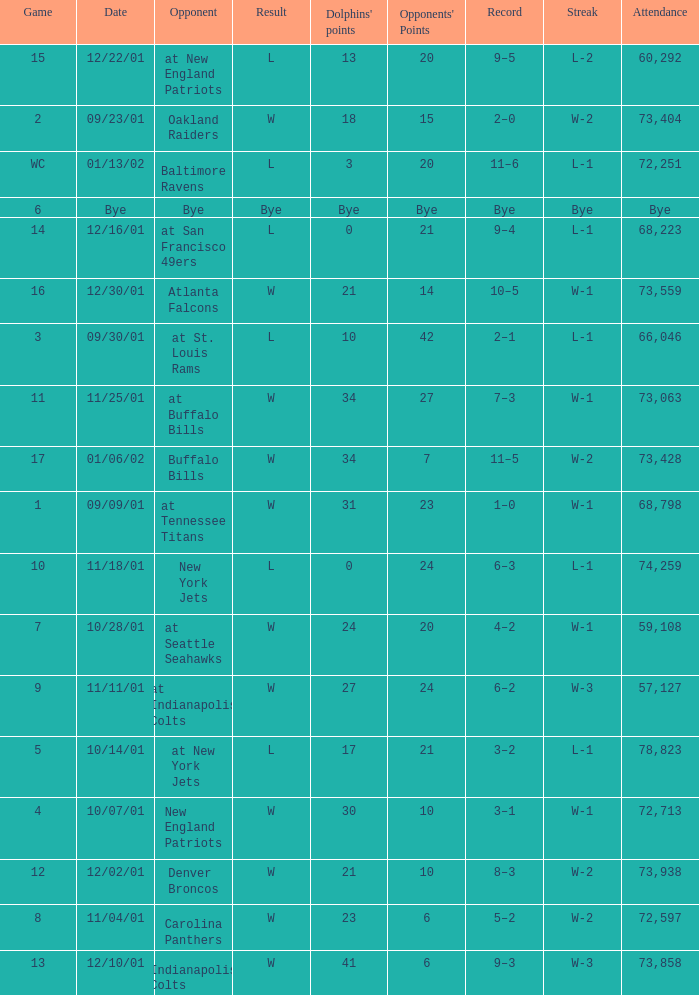How many attended the game with an opponent of bye? Bye. 